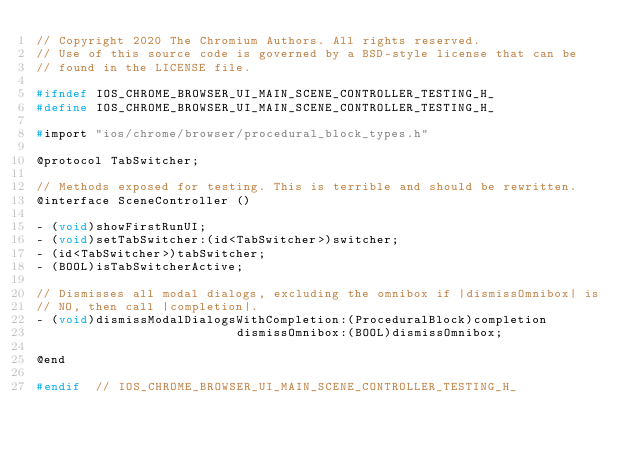<code> <loc_0><loc_0><loc_500><loc_500><_C_>// Copyright 2020 The Chromium Authors. All rights reserved.
// Use of this source code is governed by a BSD-style license that can be
// found in the LICENSE file.

#ifndef IOS_CHROME_BROWSER_UI_MAIN_SCENE_CONTROLLER_TESTING_H_
#define IOS_CHROME_BROWSER_UI_MAIN_SCENE_CONTROLLER_TESTING_H_

#import "ios/chrome/browser/procedural_block_types.h"

@protocol TabSwitcher;

// Methods exposed for testing. This is terrible and should be rewritten.
@interface SceneController ()

- (void)showFirstRunUI;
- (void)setTabSwitcher:(id<TabSwitcher>)switcher;
- (id<TabSwitcher>)tabSwitcher;
- (BOOL)isTabSwitcherActive;

// Dismisses all modal dialogs, excluding the omnibox if |dismissOmnibox| is
// NO, then call |completion|.
- (void)dismissModalDialogsWithCompletion:(ProceduralBlock)completion
                           dismissOmnibox:(BOOL)dismissOmnibox;

@end

#endif  // IOS_CHROME_BROWSER_UI_MAIN_SCENE_CONTROLLER_TESTING_H_
</code> 